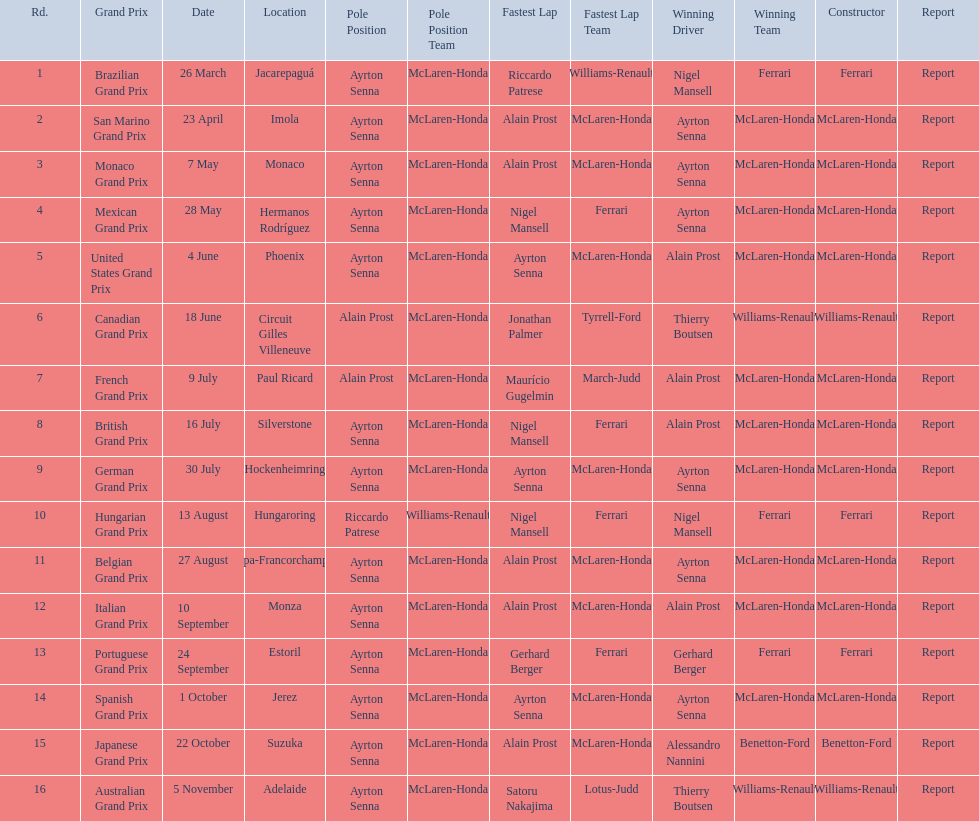How many times was ayrton senna in pole position? 13. 